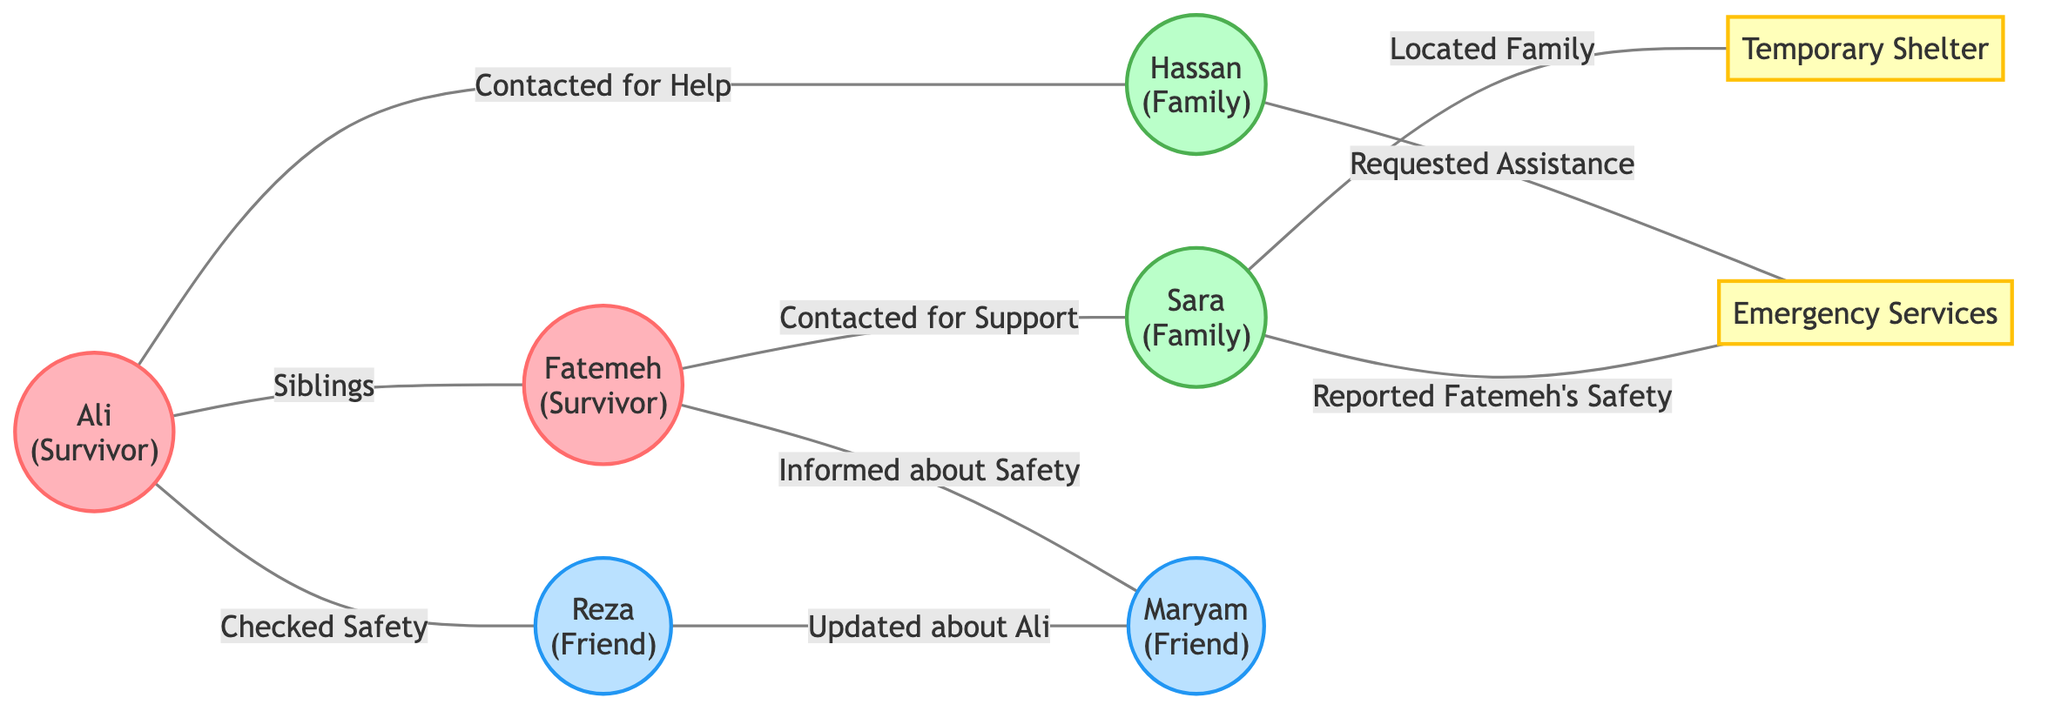What are the roles of Ali and Fatemeh in the diagram? The diagram shows that both Ali and Fatemeh are labeled as "Survivor," which indicates their role during and after the earthquake.
Answer: Survivor How many unique nodes are in the diagram? The diagram lists eight unique nodes representing individuals and services: Ali, Fatemeh, Hassan, Sara, Reza, Maryam, Emergency Services, and Temporary Shelter. Thus, the count is eight.
Answer: Eight What type of relationship exists between Ali and Hassan? The edge connecting Ali and Hassan is labeled "Contacted for Help," indicating that they have a direct relationship where Ali sought assistance from Hassan.
Answer: Contacted for Help Who informed Maryam about Ali's safety? According to the diagram, Reza is connected to Maryam with the relationship "Updated about Ali," indicating that Reza informed Maryam about Ali's safety.
Answer: Reza Which node is connected to both Fatemeh and Sara? The diagram reveals that Fatemeh is connected to Sara with the relationship "Contacted for Support." Therefore, the answer would be Sara since she is directly connected to Fatemeh.
Answer: Sara What services did Hassan request after the earthquake? The diagram shows that Hassan is connected to "Emergency Services," with the relationship "Requested Assistance." This indicates that Hassan sought help from emergency services.
Answer: Emergency Services How many friendships are represented in the diagram? There are two connections that illustrate friendships: Ali with Reza (Checked Safety) and Reza with Maryam (Updated about Ali). So, the total number of friendships is two.
Answer: Two What is the primary purpose of the Temporary Shelter node? The edge from Sara indicates that she "Located Family" linked to the Temporary Shelter, suggesting that the purpose of this node is to indicate a place of refuge during the crisis.
Answer: Location Which family member contacted Fatemeh for support after the earthquake? The diagram outlines that Fatemeh is connected to Sara through the edge labeled "Contacted for Support," meaning Sara reached out to her for assistance.
Answer: Sara 